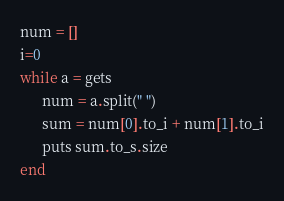Convert code to text. <code><loc_0><loc_0><loc_500><loc_500><_Ruby_>num = []
i=0
while a = gets
      num = a.split(" ")
      sum = num[0].to_i + num[1].to_i
      puts sum.to_s.size
end</code> 